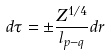Convert formula to latex. <formula><loc_0><loc_0><loc_500><loc_500>d \tau = \pm \frac { Z ^ { 1 / 4 } } { l _ { p - q } } d r</formula> 